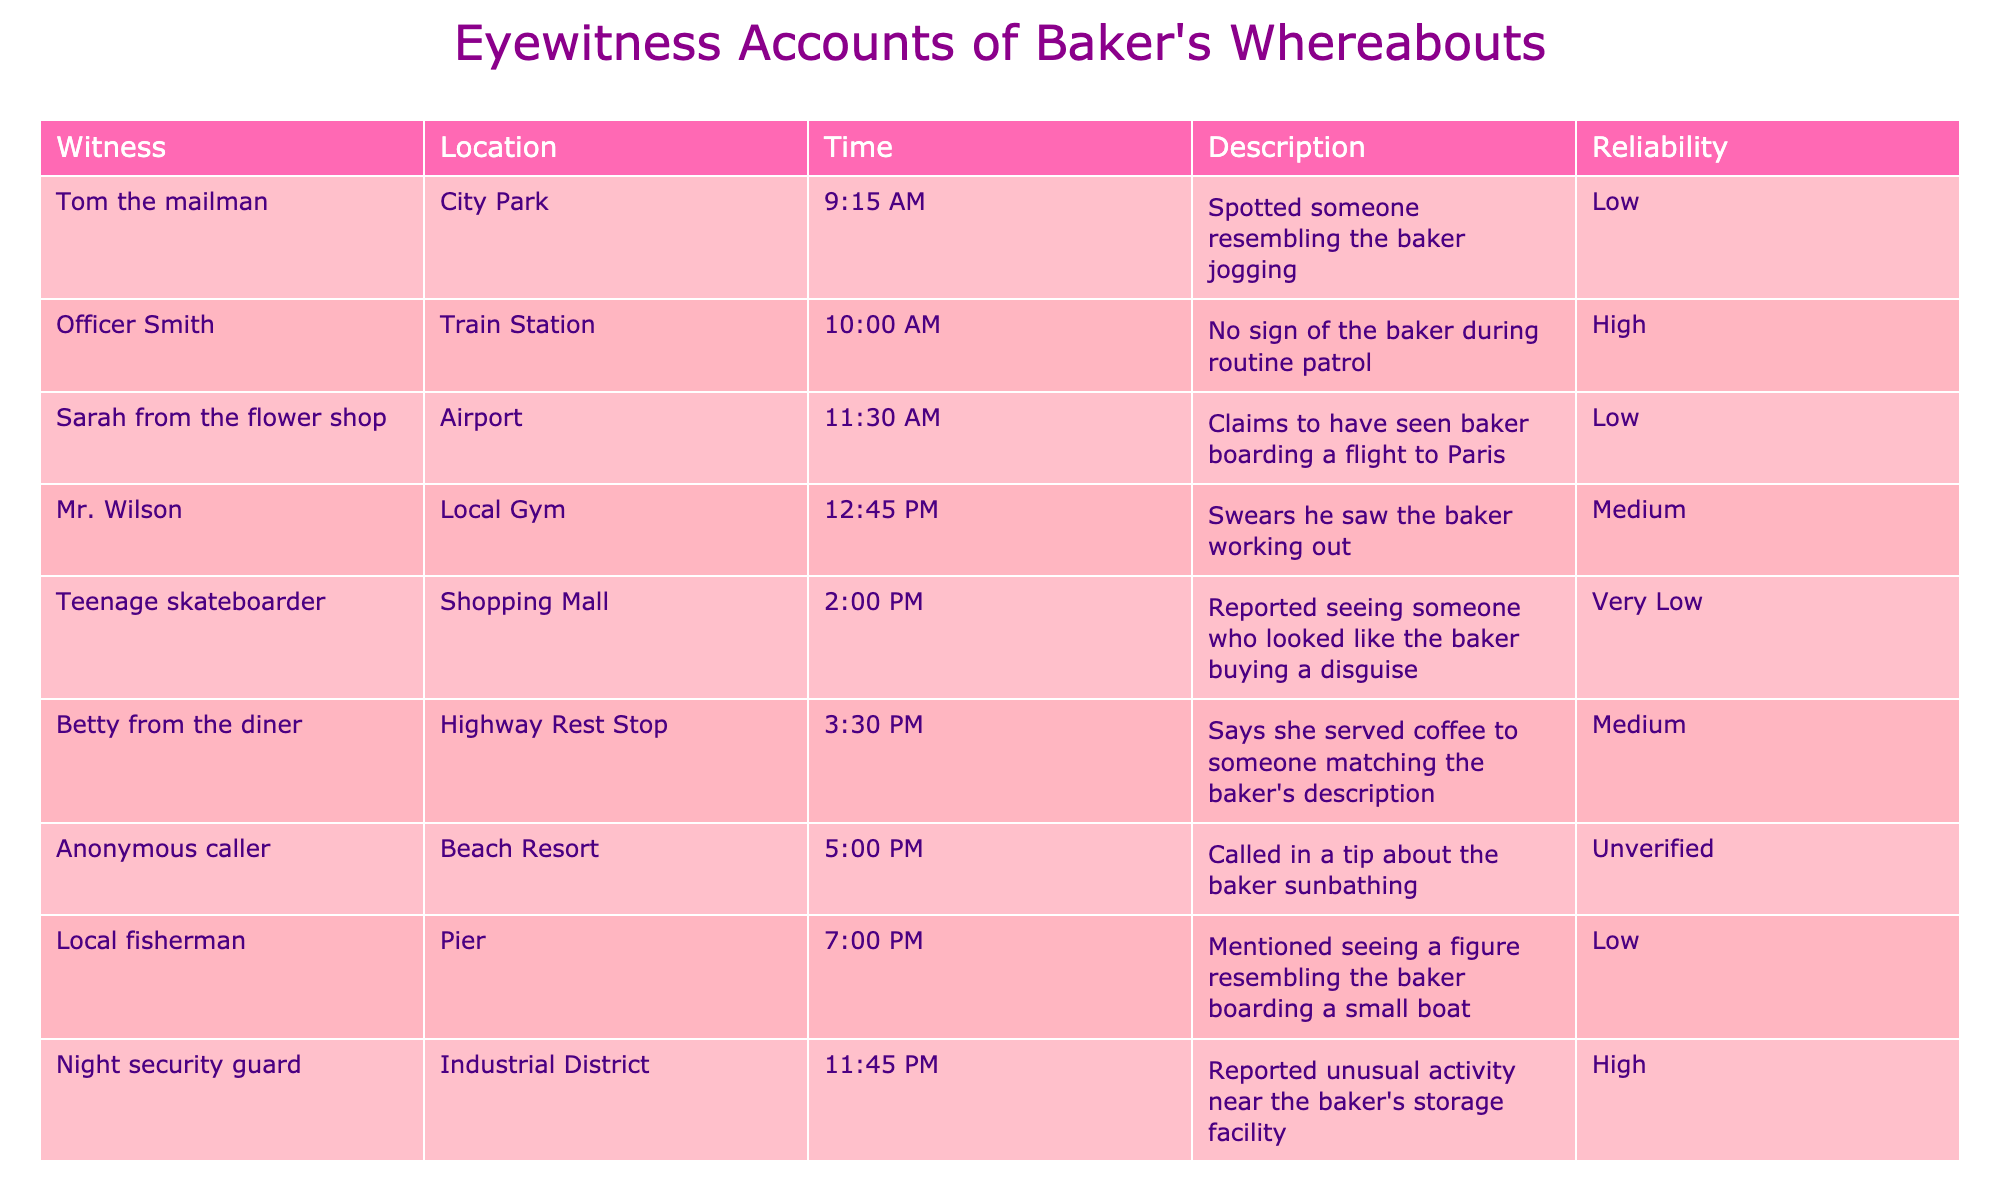What time did Sarah from the flower shop claim to see the baker? According to the table, Sarah from the flower shop reported seeing the baker at 11:30 AM. This information is retrieved directly from the "Time" column corresponding to her name in the "Witness" column.
Answer: 11:30 AM How many eyewitnesses reported seeing the baker in places with reliable accounts? The eyewitnesses with high reliability are Officer Smith and the night security guard, both providing reliable information. Therefore, there are 2 eyewitnesses who reported seeing the baker with high reliability.
Answer: 2 Did any witness report seeing the baker on a plane? According to the table, Sarah from the flower shop stated she saw the baker boarding a flight to Paris. Therefore, it is true that a witness reported seeing the baker on a plane.
Answer: Yes What is the total number of different locations mentioned in the eyewitness accounts? By reviewing the "Location" column in the table, the distinct locations mentioned are City Park, Train Station, Airport, Local Gym, Shopping Mall, Highway Rest Stop, Beach Resort, Pier, and Industrial District. This totals up to 9 unique locations.
Answer: 9 Who witnessed the baker at 2:00 PM? The eyewitness who reported seeing the baker at 2:00 PM is the teenage skateboarder, as noted in the "Time" column corresponding to that specific time.
Answer: Teenage skateboarder 